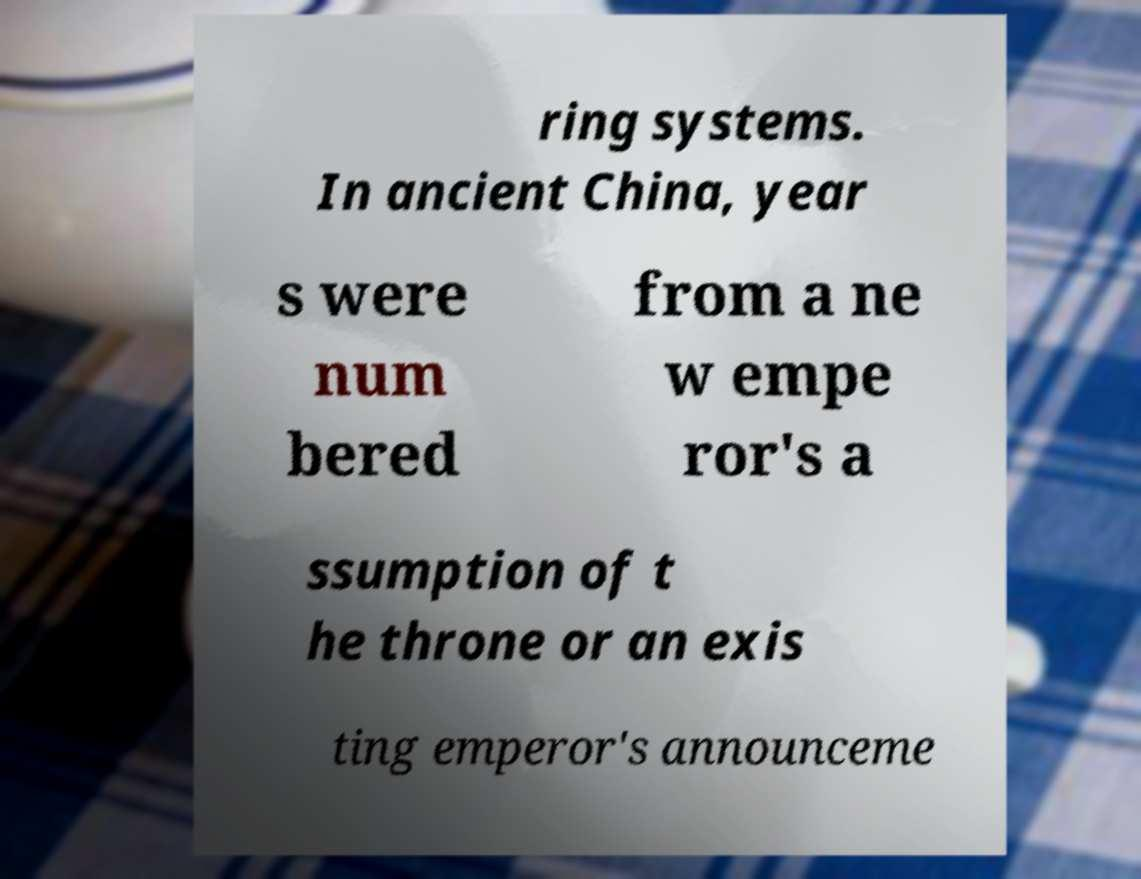Could you assist in decoding the text presented in this image and type it out clearly? ring systems. In ancient China, year s were num bered from a ne w empe ror's a ssumption of t he throne or an exis ting emperor's announceme 